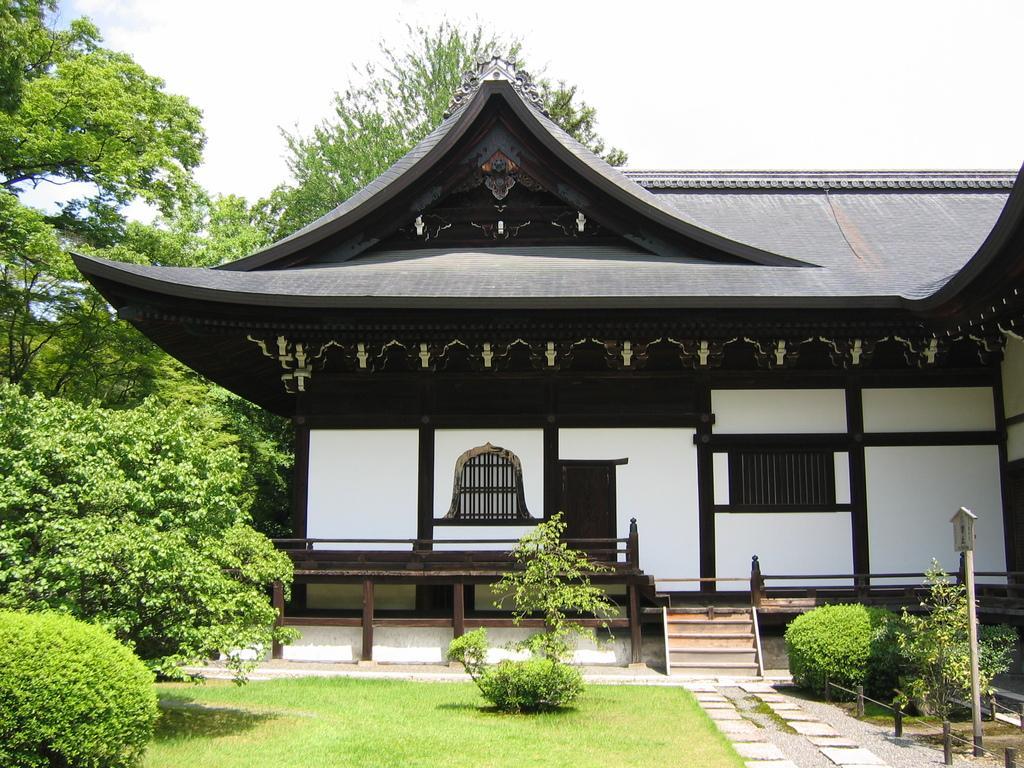Describe this image in one or two sentences. On the left side, there are plants, trees and grass on the ground. On the right side, there is a path. Beside this path, there are plants and a pole on the ground. In the background, there is a building having roof and windows and there are clouds in the sky. 